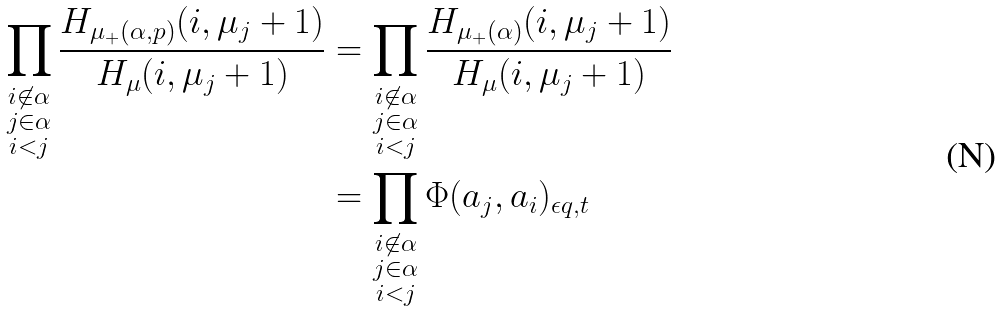<formula> <loc_0><loc_0><loc_500><loc_500>\prod _ { \substack { i \not \in \alpha \\ j \in \alpha \\ i < j } } \frac { H _ { \mu _ { + } ( \alpha , p ) } ( i , \mu _ { j } + 1 ) } { H _ { \mu } ( i , \mu _ { j } + 1 ) } & = \prod _ { \substack { i \not \in \alpha \\ j \in \alpha \\ i < j } } \frac { H _ { \mu _ { + } ( \alpha ) } ( i , \mu _ { j } + 1 ) } { H _ { \mu } ( i , \mu _ { j } + 1 ) } \\ & = \prod _ { \substack { i \not \in \alpha \\ j \in \alpha \\ i < j } } \Phi ( a _ { j } , a _ { i } ) _ { \epsilon q , t }</formula> 